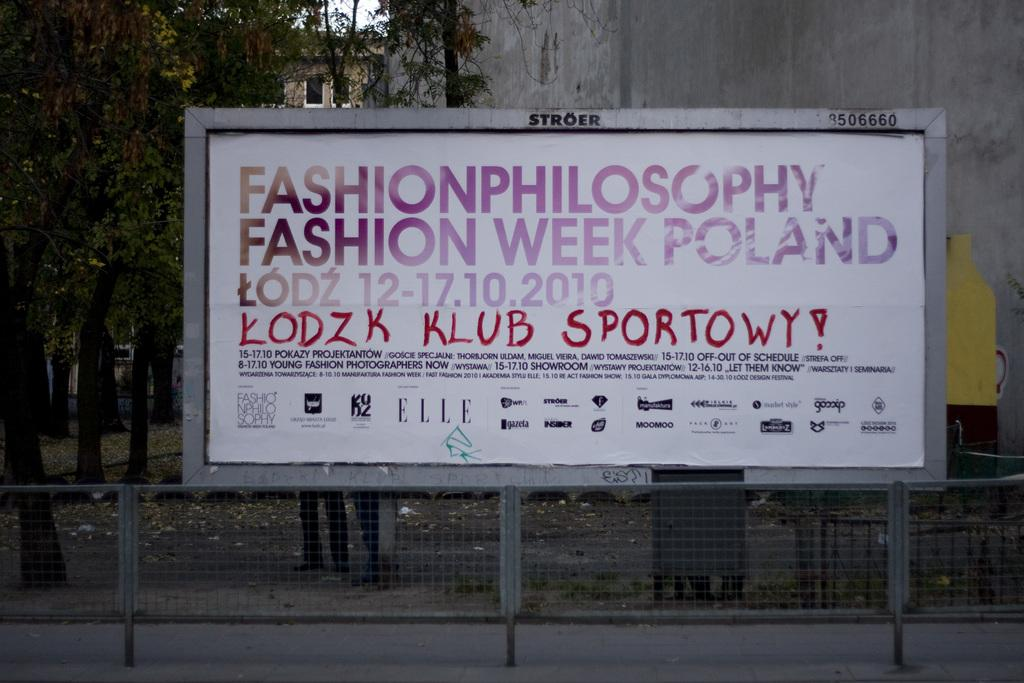<image>
Describe the image concisely. A billboard that reads fashionphilosophy fashion week poland. 